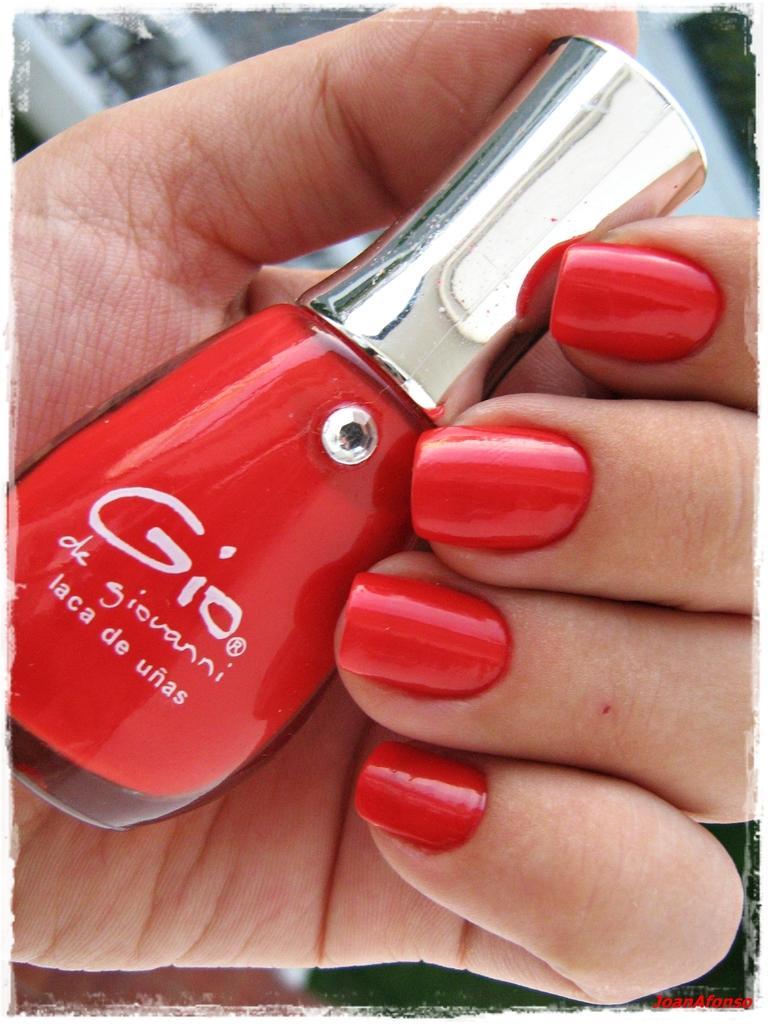Could you give a brief overview of what you see in this image? In this picture we can see a nail polish bottle in a person's hand and in the background it is blurry. 